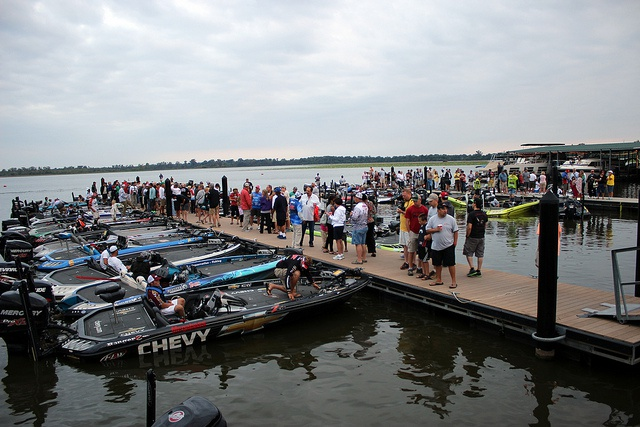Describe the objects in this image and their specific colors. I can see people in lightgray, black, gray, and darkgray tones, boat in lightgray, black, gray, darkgray, and purple tones, boat in lightgray, black, gray, and darkgray tones, boat in lightgray, black, gray, darkgray, and navy tones, and boat in lightgray, darkgray, black, gray, and blue tones in this image. 